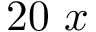Convert formula to latex. <formula><loc_0><loc_0><loc_500><loc_500>2 0 x</formula> 